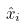Convert formula to latex. <formula><loc_0><loc_0><loc_500><loc_500>\hat { x } _ { i }</formula> 